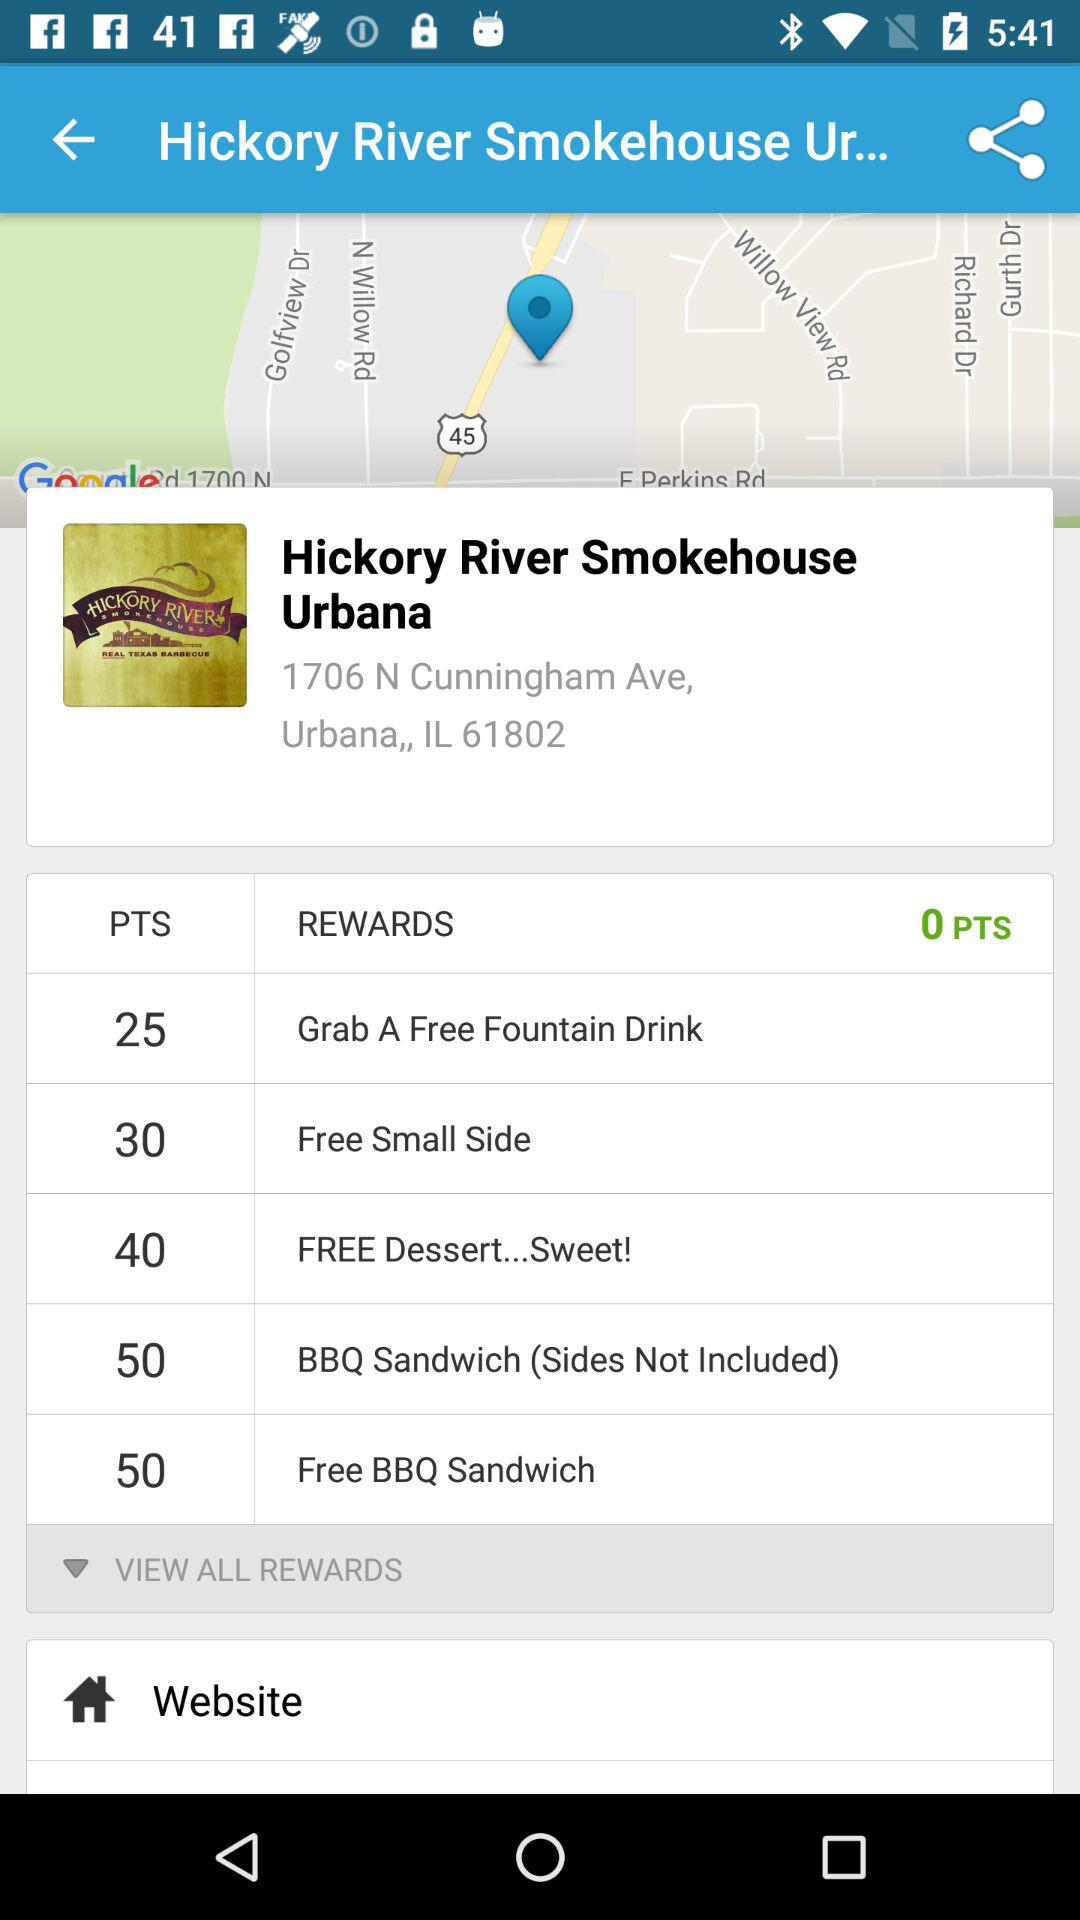How many points do I need to redeem for a free BBQ sandwich?
Answer the question using a single word or phrase. 50 